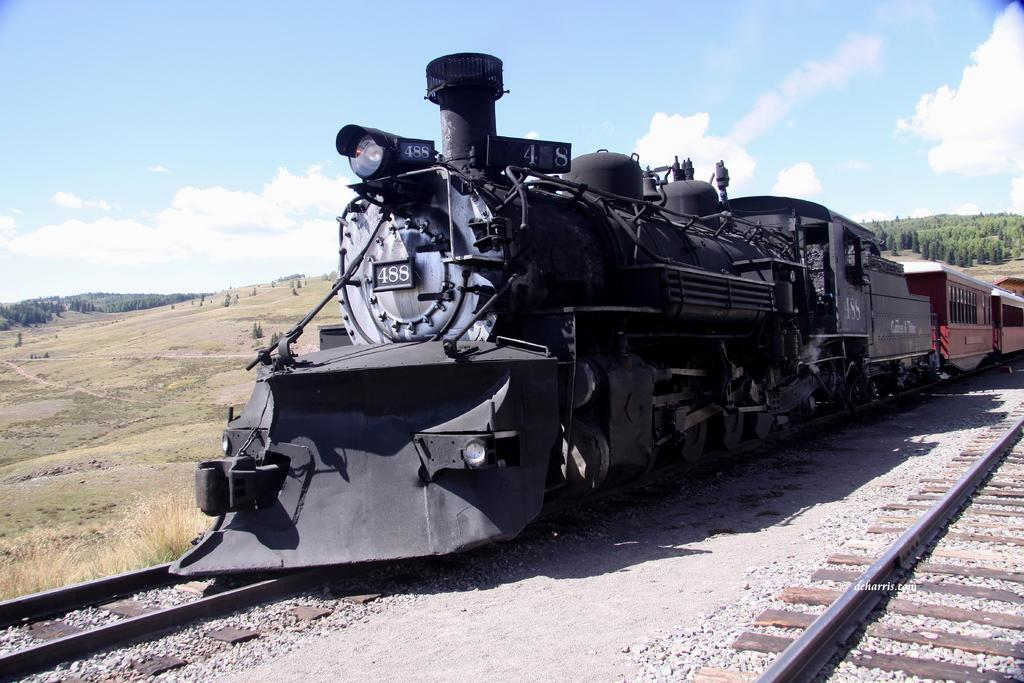What is the main subject of the image? The main subject of the image is a train. Where is the train located in the image? The train is on a railway track. What type of vegetation can be seen in the image? There is grass visible in the image, and there are also trees. How would you describe the weather in the image? The sky is cloudy in the image, which suggests a potentially overcast or rainy day. How long does the train's voyage take in the image? The image does not provide information about the duration of the train's voyage, as it only shows the train on a railway track. 